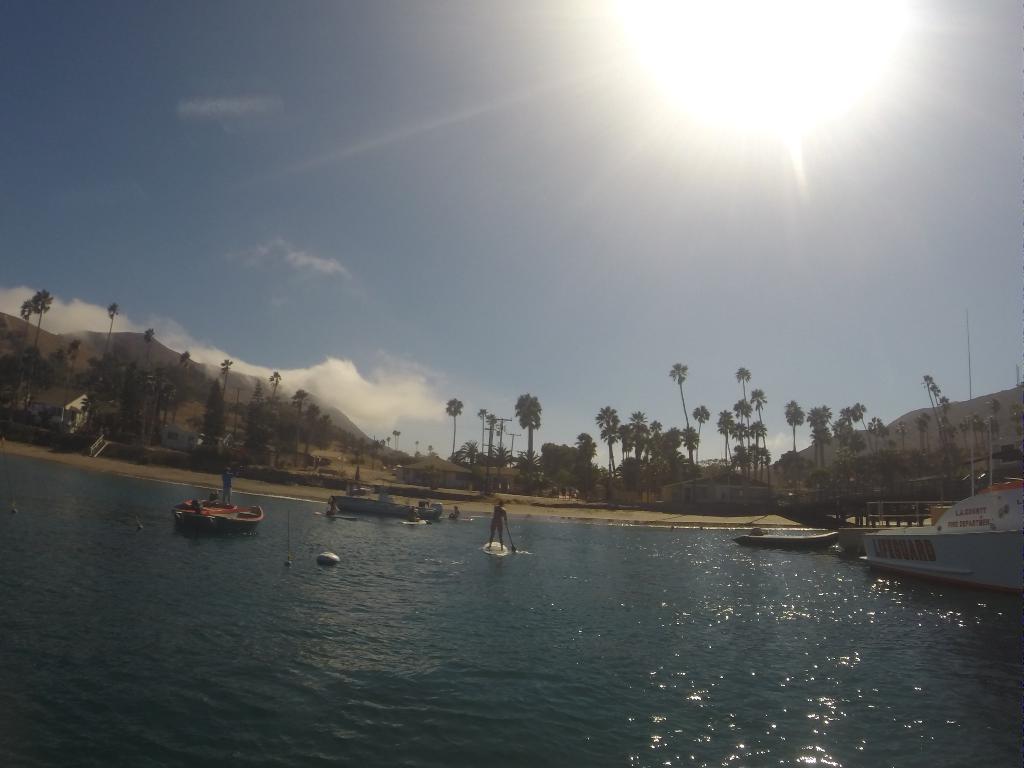Can you describe this image briefly? In this image there is a river, in that river there are boats, in the background there are trees and houses and mountains and a sky. 